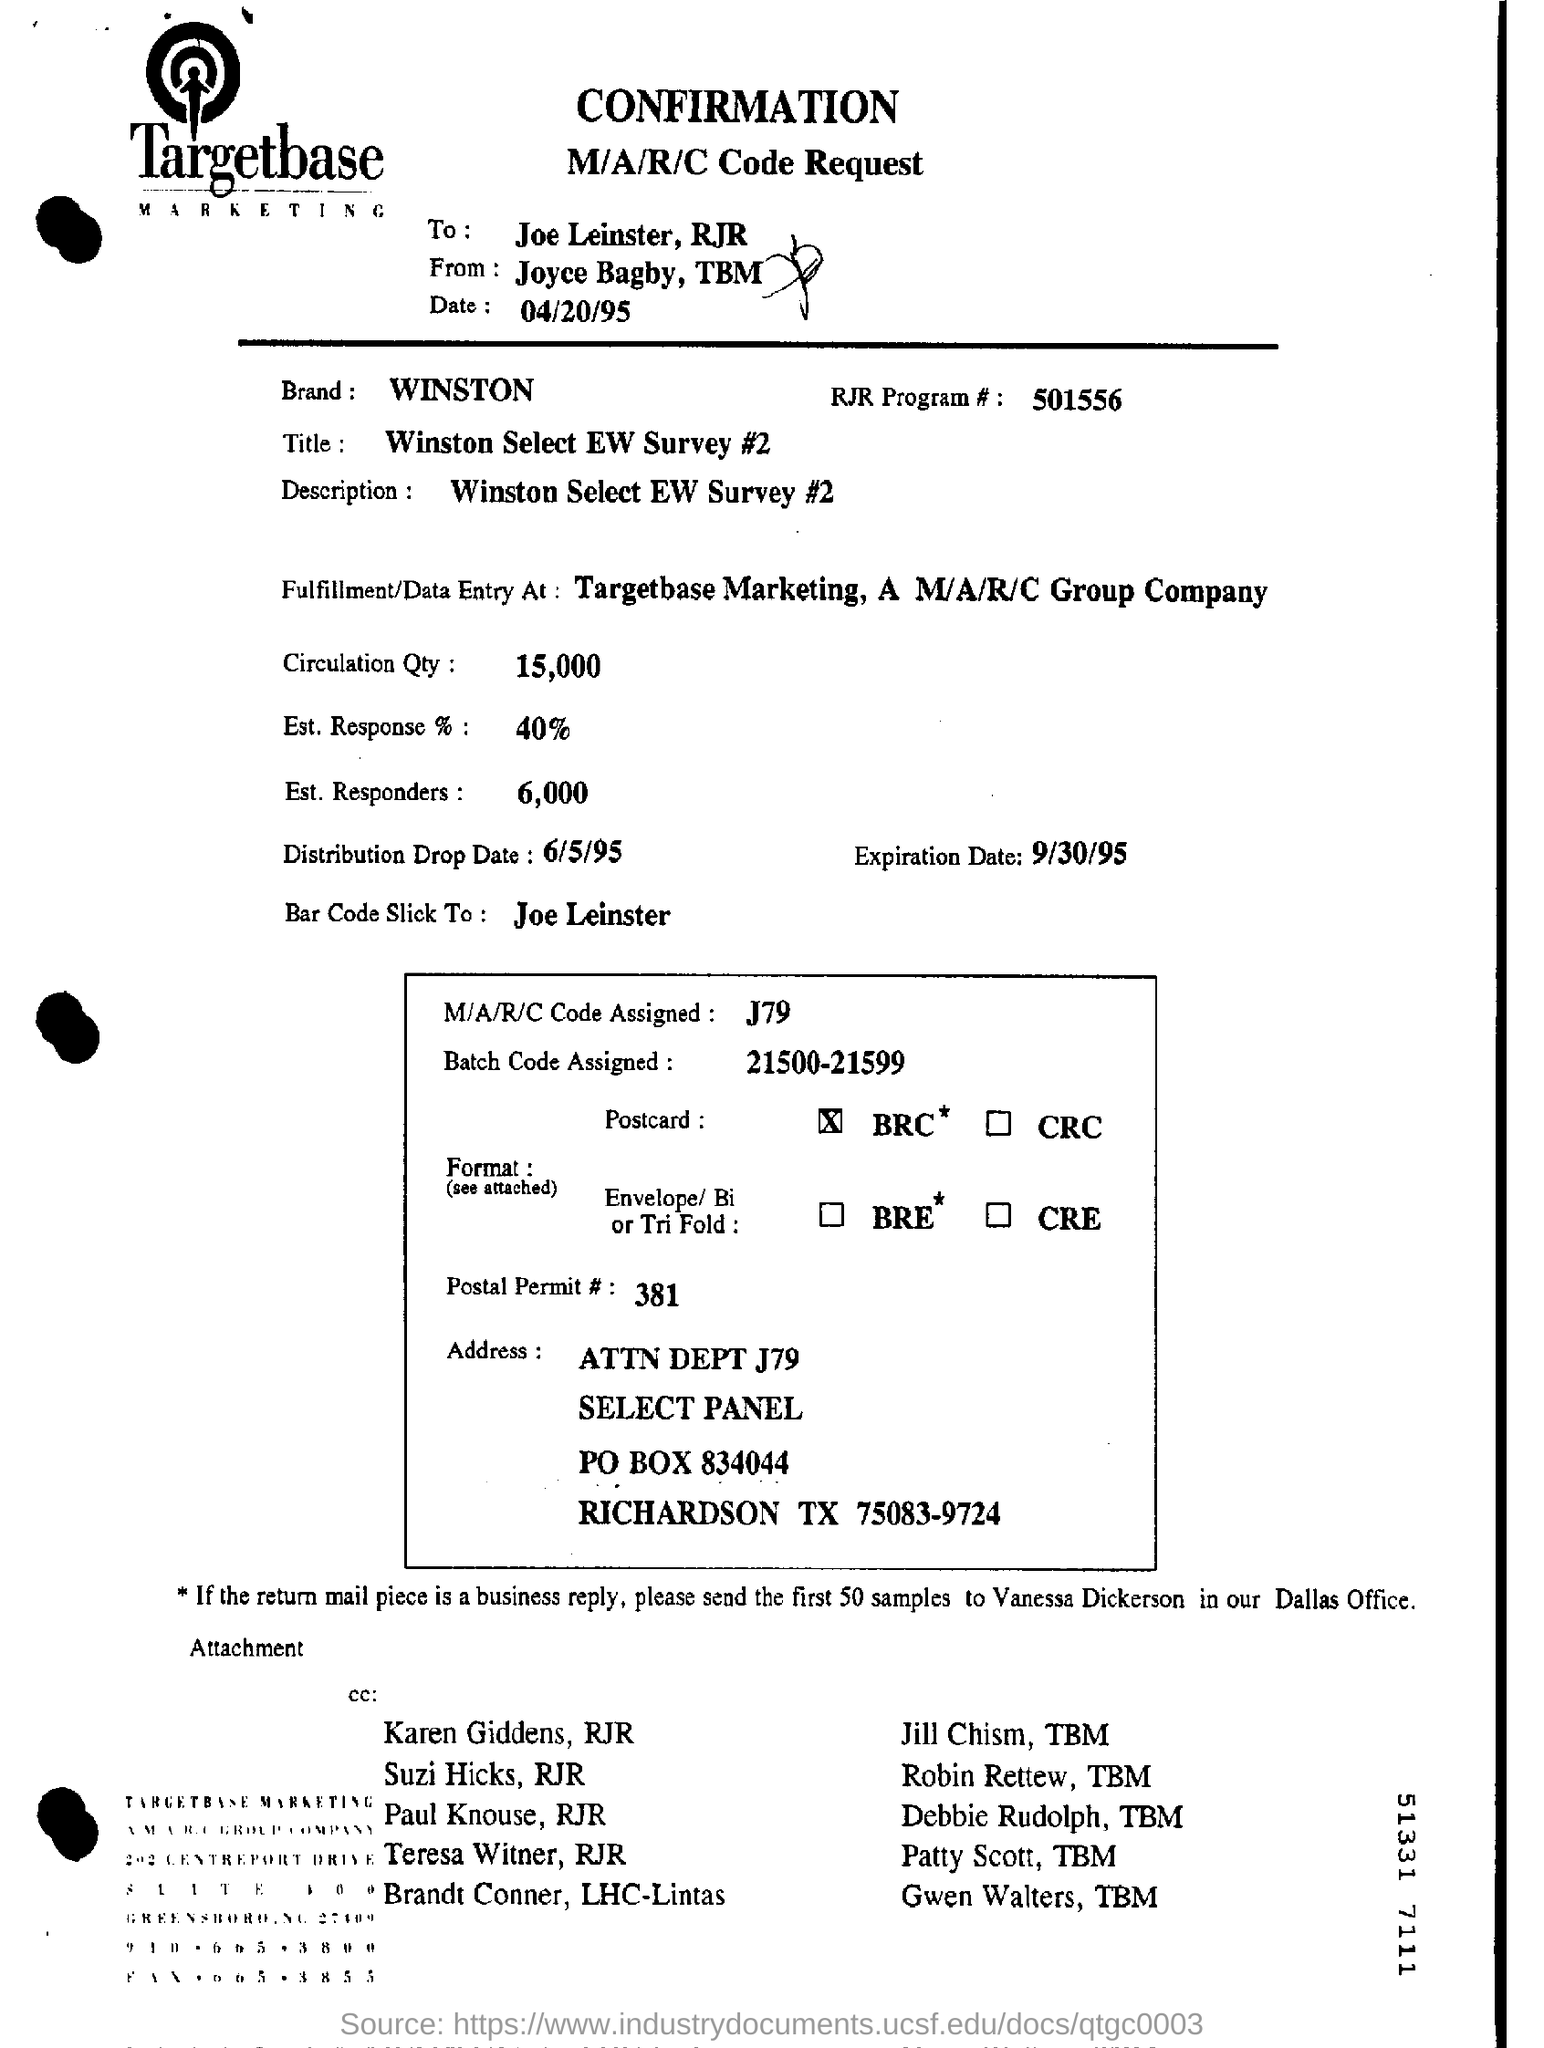Which is the RJR Program #?
Keep it short and to the point. 501556. What is the title of the survey?
Keep it short and to the point. Winston Select EW Survey #2. How much is the Circulation Qty?
Your response must be concise. 15000. What is the Expiration Date?
Keep it short and to the point. 9/30/95. What is the estimated number of responders?
Keep it short and to the point. 6,000. What is the batch code assigned?
Your answer should be very brief. 21500-21599. 